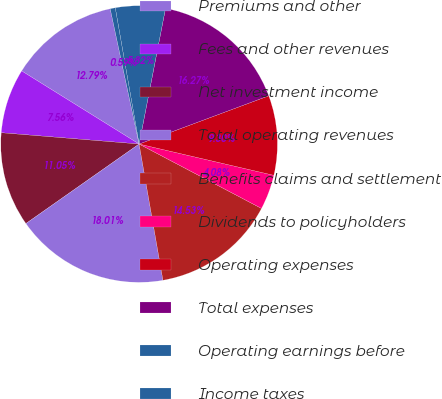Convert chart to OTSL. <chart><loc_0><loc_0><loc_500><loc_500><pie_chart><fcel>Premiums and other<fcel>Fees and other revenues<fcel>Net investment income<fcel>Total operating revenues<fcel>Benefits claims and settlement<fcel>Dividends to policyholders<fcel>Operating expenses<fcel>Total expenses<fcel>Operating earnings before<fcel>Income taxes<nl><fcel>12.79%<fcel>7.56%<fcel>11.05%<fcel>18.01%<fcel>14.53%<fcel>4.08%<fcel>9.3%<fcel>16.27%<fcel>5.82%<fcel>0.59%<nl></chart> 